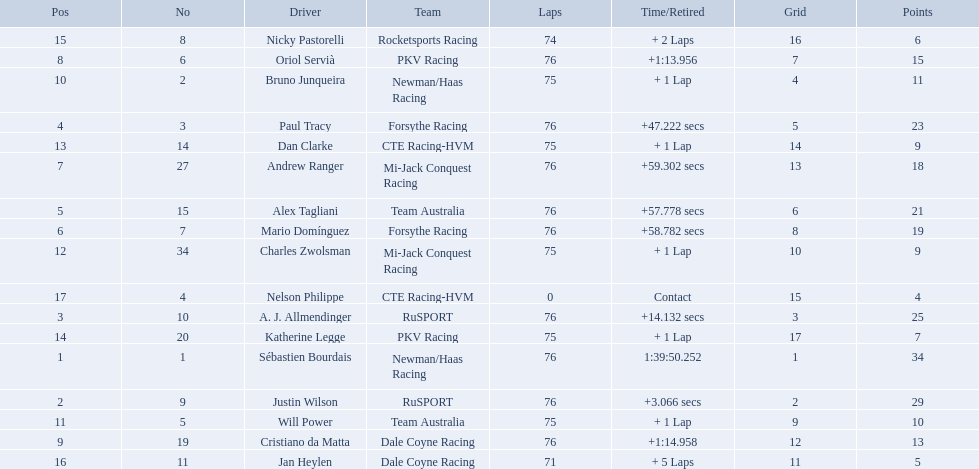What drivers took part in the 2006 tecate grand prix of monterrey? Sébastien Bourdais, Justin Wilson, A. J. Allmendinger, Paul Tracy, Alex Tagliani, Mario Domínguez, Andrew Ranger, Oriol Servià, Cristiano da Matta, Bruno Junqueira, Will Power, Charles Zwolsman, Dan Clarke, Katherine Legge, Nicky Pastorelli, Jan Heylen, Nelson Philippe. Which of those drivers scored the same amount of points as another driver? Charles Zwolsman, Dan Clarke. Who had the same amount of points as charles zwolsman? Dan Clarke. 